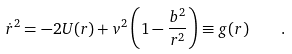<formula> <loc_0><loc_0><loc_500><loc_500>\dot { r } ^ { 2 } = - 2 U ( r ) + v ^ { 2 } \left ( 1 - \frac { b ^ { 2 } } { r ^ { 2 } } \right ) \equiv g ( r ) \quad .</formula> 